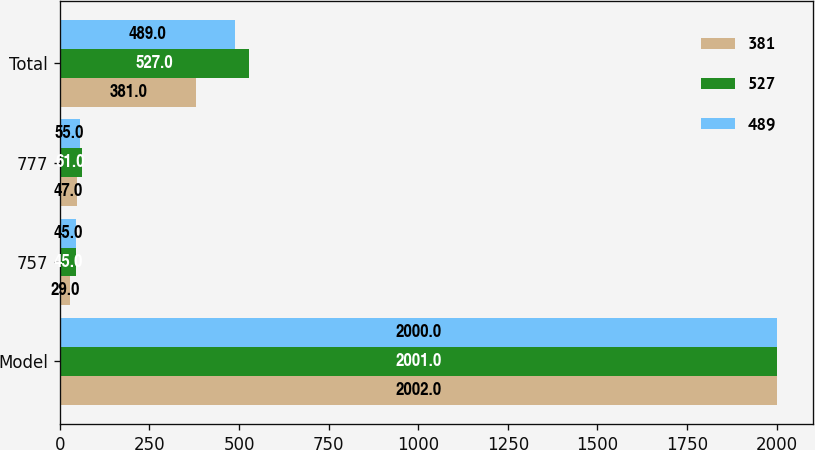Convert chart to OTSL. <chart><loc_0><loc_0><loc_500><loc_500><stacked_bar_chart><ecel><fcel>Model<fcel>757<fcel>777<fcel>Total<nl><fcel>381<fcel>2002<fcel>29<fcel>47<fcel>381<nl><fcel>527<fcel>2001<fcel>45<fcel>61<fcel>527<nl><fcel>489<fcel>2000<fcel>45<fcel>55<fcel>489<nl></chart> 